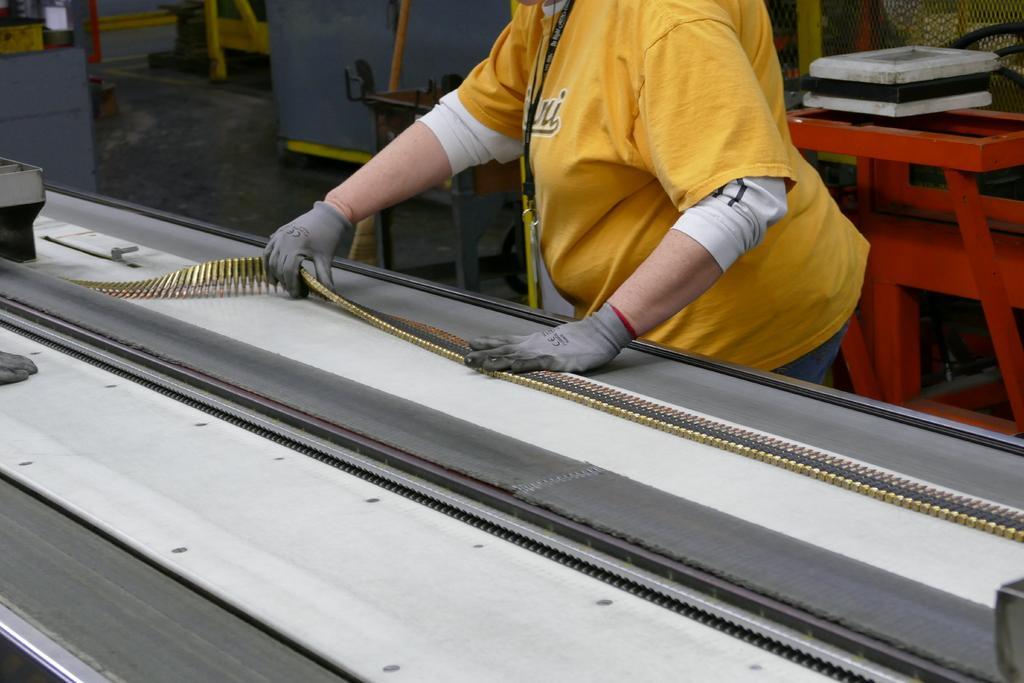Could you give a brief overview of what you see in this image? In the middle of the image we can see a person, the person wore a yellow color t-shirt, in front of the person we can find few bullets. 